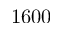Convert formula to latex. <formula><loc_0><loc_0><loc_500><loc_500>1 6 0 0</formula> 